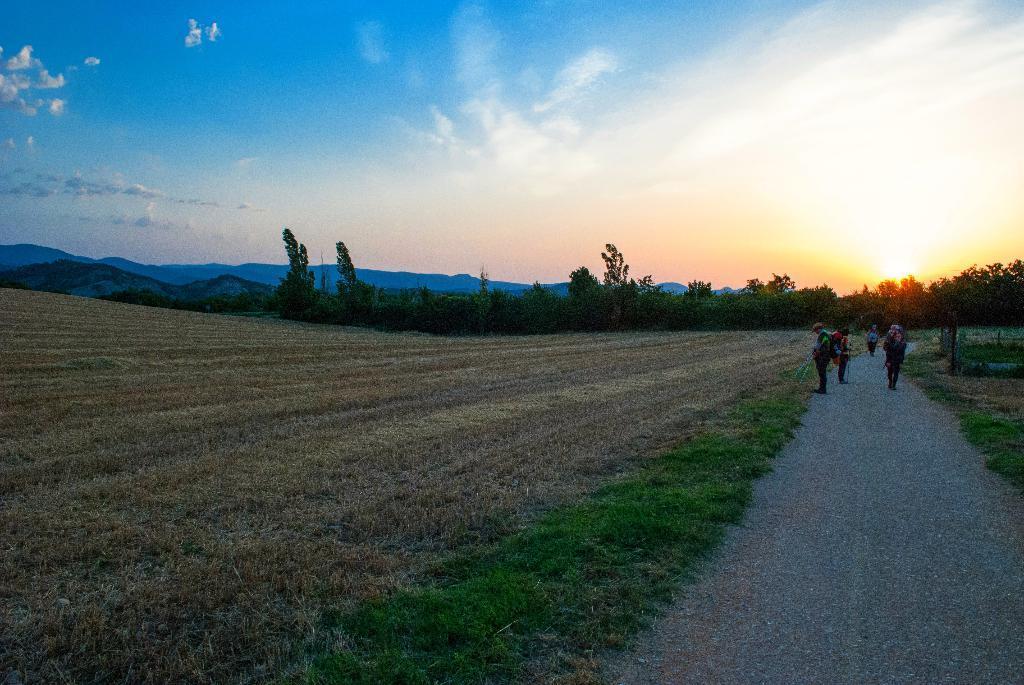How would you summarize this image in a sentence or two? In a given image I can see a tree, people, sky, mountains and clouds. 